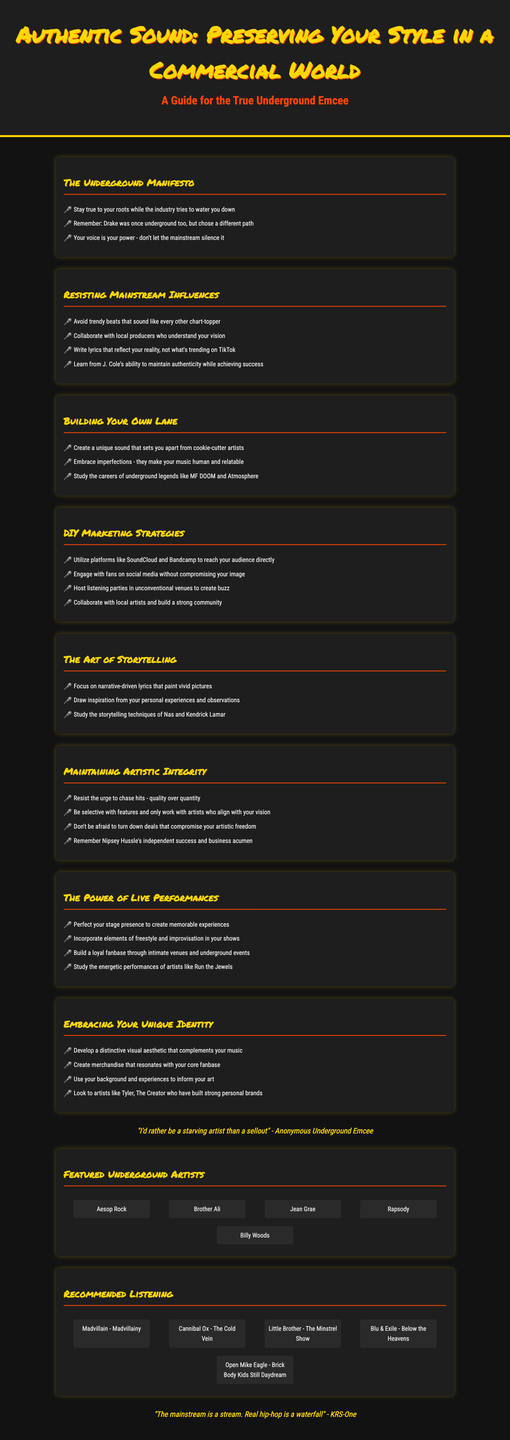What is the title of the brochure? The title is prominently displayed at the top of the document, indicating the primary focus of the content.
Answer: Authentic Sound: Preserving Your Style in a Commercial World Who is the brochure intended for? The subtitle clarifies the target audience of the brochure, providing insight into its purpose.
Answer: True Underground Emcee What is one way to resist mainstream influences? The document provides several suggestions on how to maintain authenticity, one of which is listed in the relevant section.
Answer: Avoid trendy beats that sound like every other chart-topper Name one featured underground artist. Several artists are mentioned in the brochure, which highlights their significance within the underground rap scene.
Answer: Aesop Rock Which artist's career is suggested as a model for maintaining authenticity? The brochure mentions examples of successful artists while preserving their unique styles, offering insights for readers.
Answer: J. Cole What is one recommended listening album? A section of the brochure lists specific music albums that embody the underground style, providing readers with resources to explore.
Answer: Madvillain - Madvillainy What quote reflects the attitude of underground artists? The brochure includes notable quotes to emphasize the values of the underground hip-hop community.
Answer: "I'd rather be a starving artist than a sellout" What is emphasized in the section about live performances? This section focuses on elements that contribute to a memorable experience for the audience, highlighting a key aspect of performance arts.
Answer: Perfect your stage presence to create memorable experiences 